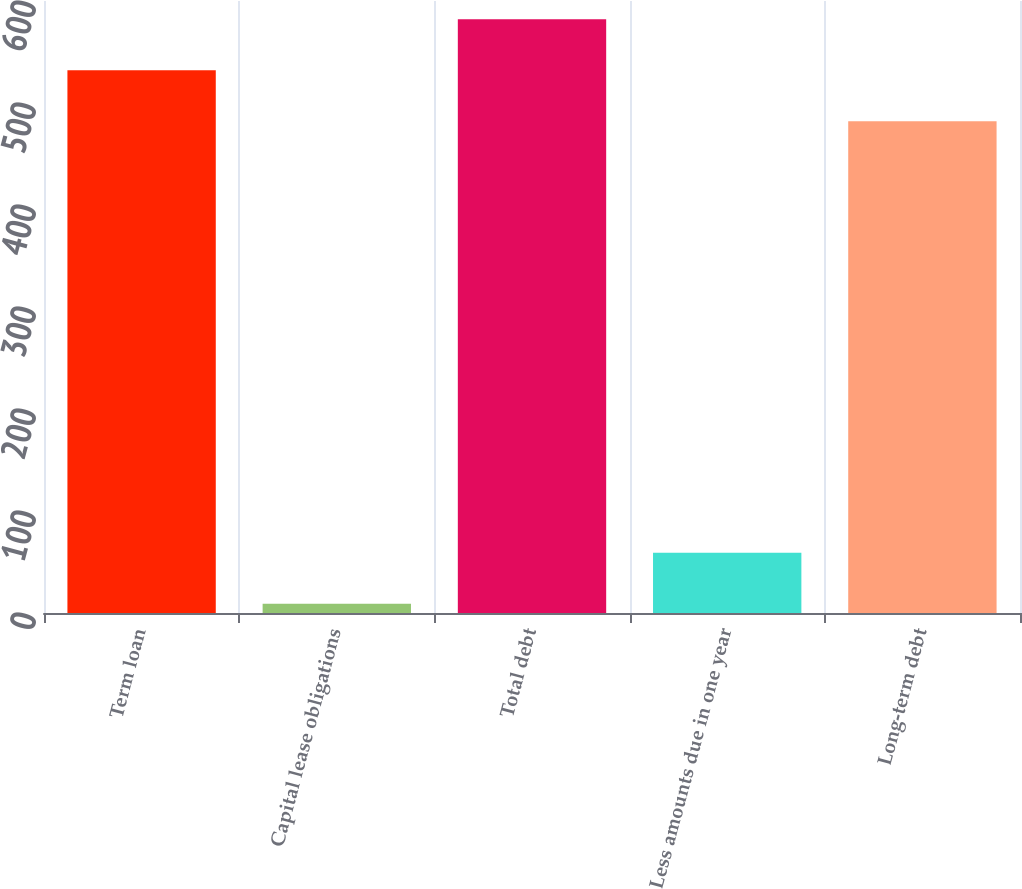<chart> <loc_0><loc_0><loc_500><loc_500><bar_chart><fcel>Term loan<fcel>Capital lease obligations<fcel>Total debt<fcel>Less amounts due in one year<fcel>Long-term debt<nl><fcel>532<fcel>9<fcel>582<fcel>59<fcel>482<nl></chart> 